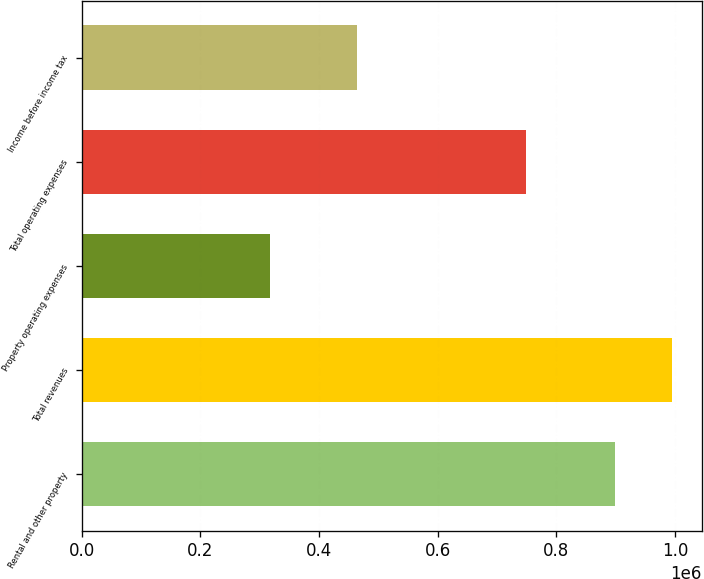Convert chart to OTSL. <chart><loc_0><loc_0><loc_500><loc_500><bar_chart><fcel>Rental and other property<fcel>Total revenues<fcel>Property operating expenses<fcel>Total operating expenses<fcel>Income before income tax<nl><fcel>899891<fcel>995854<fcel>317957<fcel>749058<fcel>464431<nl></chart> 